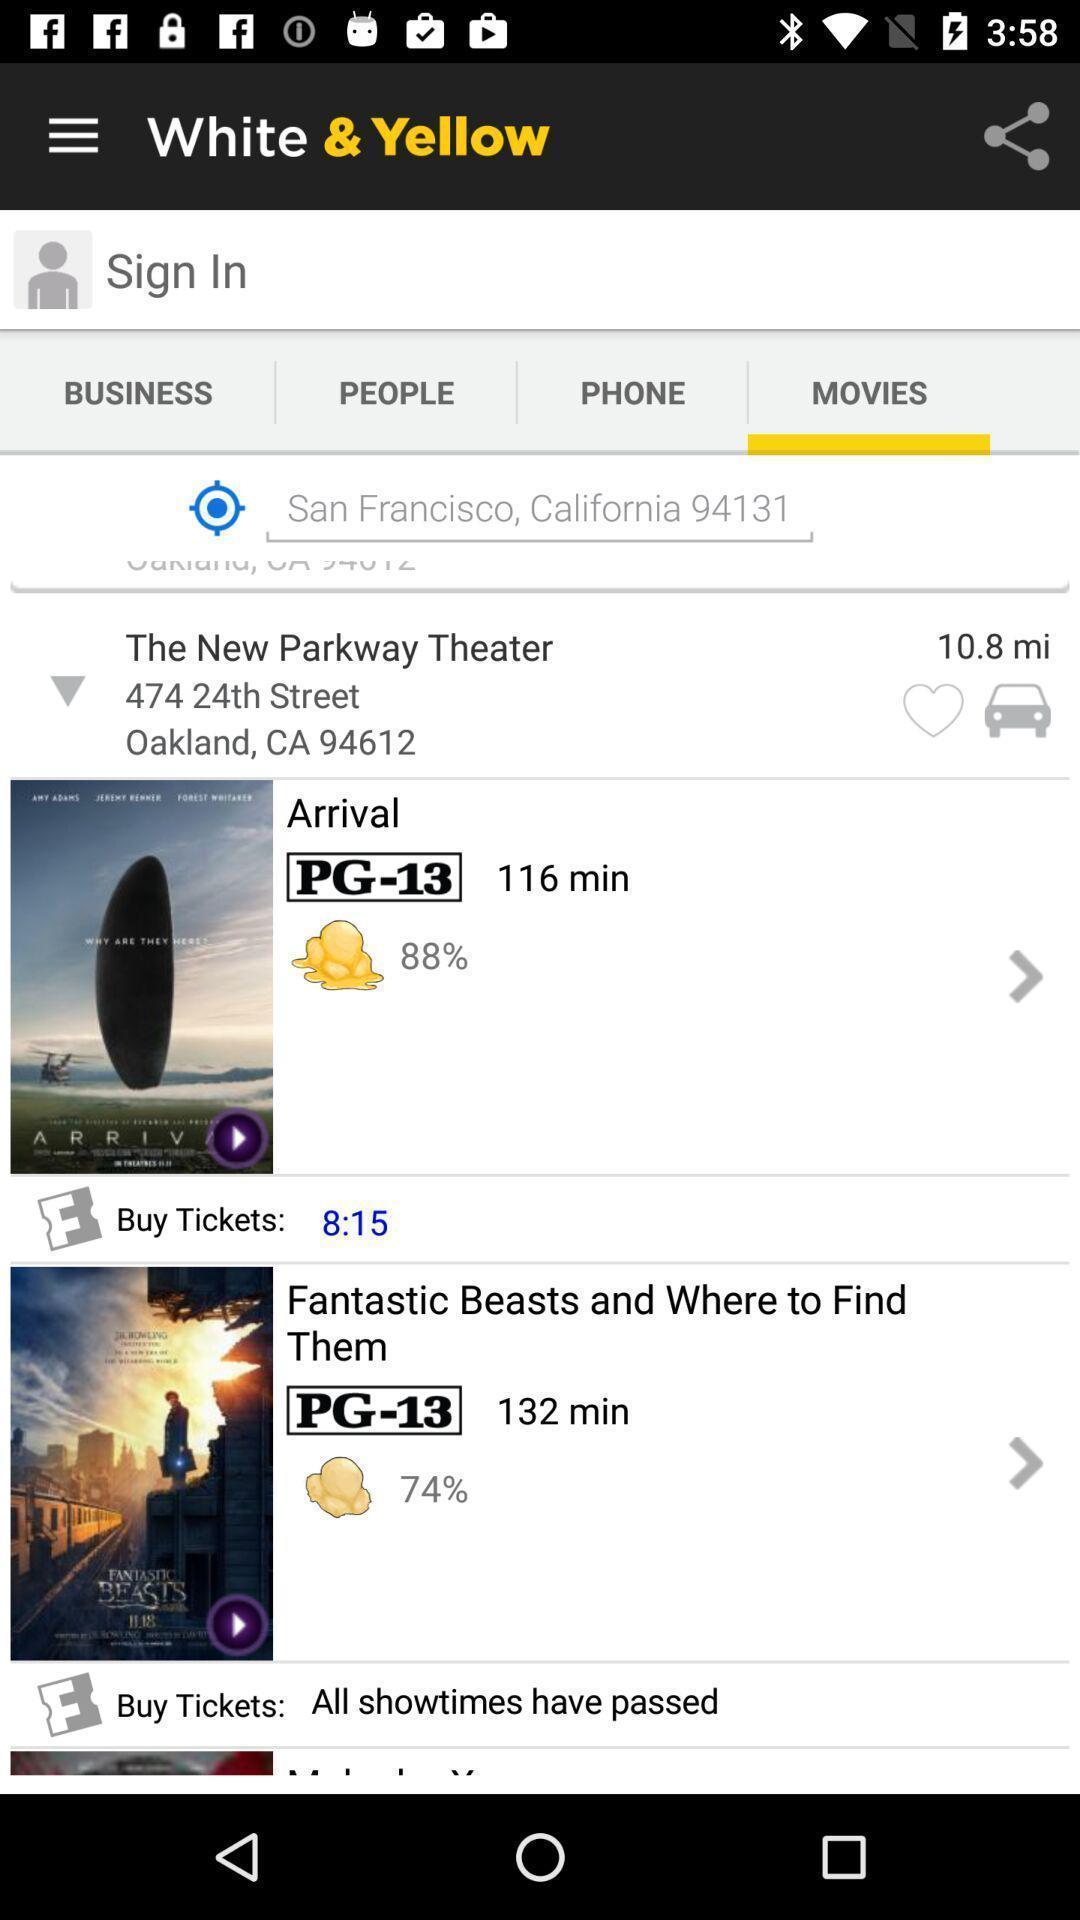Explain what's happening in this screen capture. Page showing movies list in app. 